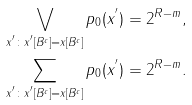<formula> <loc_0><loc_0><loc_500><loc_500>& \bigvee _ { x ^ { ^ { \prime } } \colon x ^ { ^ { \prime } } [ B ^ { c } ] = x [ B ^ { c } ] } p _ { 0 } ( x ^ { ^ { \prime } } ) = 2 ^ { R - m } , \\ & \sum _ { x ^ { ^ { \prime } } \colon x ^ { ^ { \prime } } [ B ^ { c } ] = x [ B ^ { c } ] } p _ { 0 } ( x ^ { ^ { \prime } } ) = 2 ^ { R - m } .</formula> 